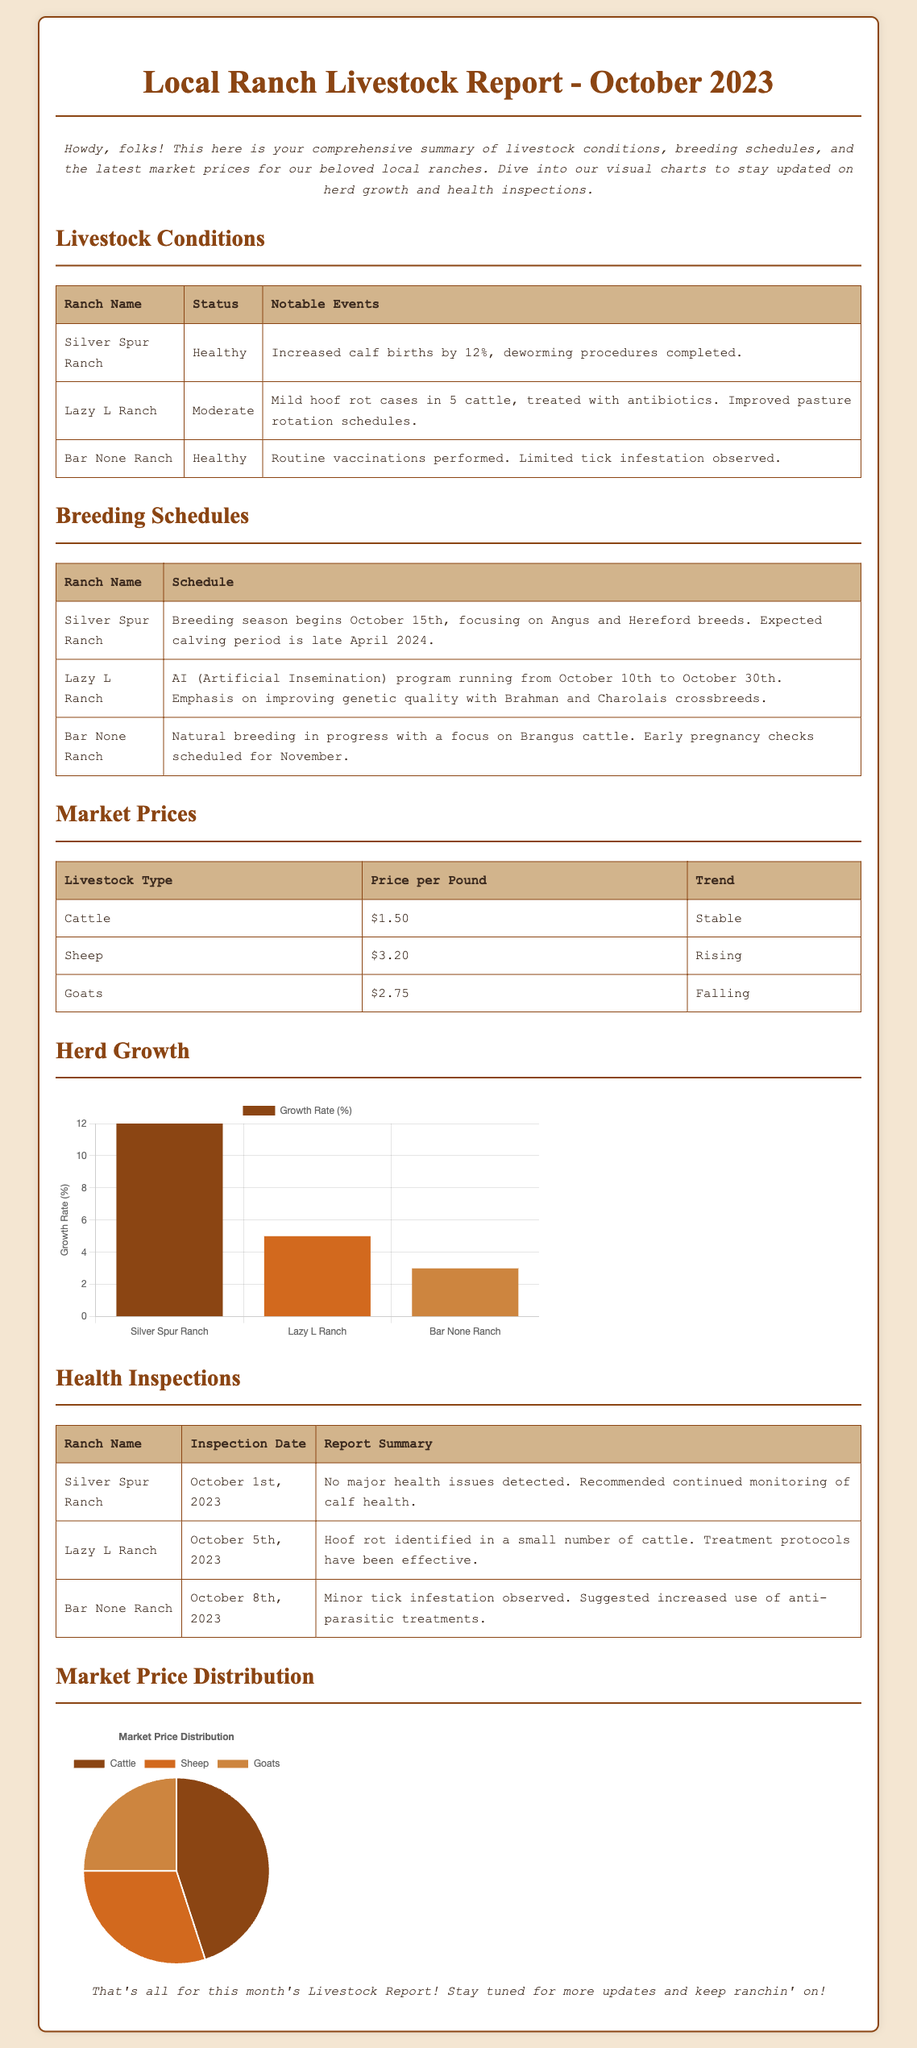What is the status of Silver Spur Ranch? The status section lists livestock conditions, where Silver Spur Ranch is noted as "Healthy."
Answer: Healthy When does breeding season begin at Silver Spur Ranch? The breeding schedule specifies that it begins on October 15th.
Answer: October 15th What is the price per pound for sheep? The market prices table specifies that sheep are priced at $3.20 per pound.
Answer: $3.20 What notable event occurred at Lazy L Ranch? The livestock conditions detail that Lazy L Ranch had mild hoof rot cases in 5 cattle, treated with antibiotics.
Answer: Mild hoof rot cases What was observed during the health inspection at Bar None Ranch? The inspection reports summarize that a minor tick infestation was observed at Bar None Ranch.
Answer: Minor tick infestation What is the growth rate percentage for Silver Spur Ranch? The herd growth chart indicates that the growth rate for Silver Spur Ranch is 12%.
Answer: 12% Which ranch specializes in Brahman and Charolais crossbreeds during AI? The breeding schedule states that Lazy L Ranch emphasizes Brahman and Charolais crossbreeds.
Answer: Lazy L Ranch Which livestock type's market price is falling? The market prices note that goat prices are falling.
Answer: Goats What is the market price distribution percentage for cattle? The market price distribution chart shows that cattle account for 45% of the distribution.
Answer: 45% 